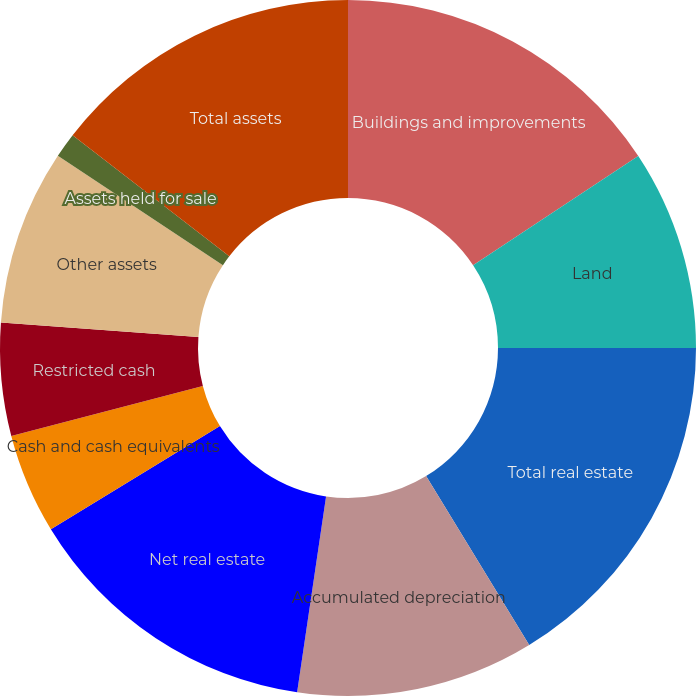<chart> <loc_0><loc_0><loc_500><loc_500><pie_chart><fcel>Buildings and improvements<fcel>Land<fcel>Total real estate<fcel>Accumulated depreciation<fcel>Net real estate<fcel>Cash and cash equivalents<fcel>Restricted cash<fcel>Other assets<fcel>Assets held for sale<fcel>Total assets<nl><fcel>15.7%<fcel>9.3%<fcel>16.28%<fcel>11.05%<fcel>13.95%<fcel>4.65%<fcel>5.23%<fcel>8.14%<fcel>1.16%<fcel>14.53%<nl></chart> 